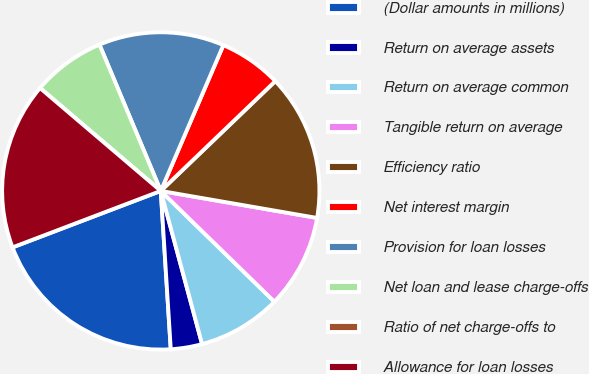Convert chart. <chart><loc_0><loc_0><loc_500><loc_500><pie_chart><fcel>(Dollar amounts in millions)<fcel>Return on average assets<fcel>Return on average common<fcel>Tangible return on average<fcel>Efficiency ratio<fcel>Net interest margin<fcel>Provision for loan losses<fcel>Net loan and lease charge-offs<fcel>Ratio of net charge-offs to<fcel>Allowance for loan losses<nl><fcel>20.21%<fcel>3.19%<fcel>8.51%<fcel>9.57%<fcel>14.89%<fcel>6.38%<fcel>12.77%<fcel>7.45%<fcel>0.0%<fcel>17.02%<nl></chart> 